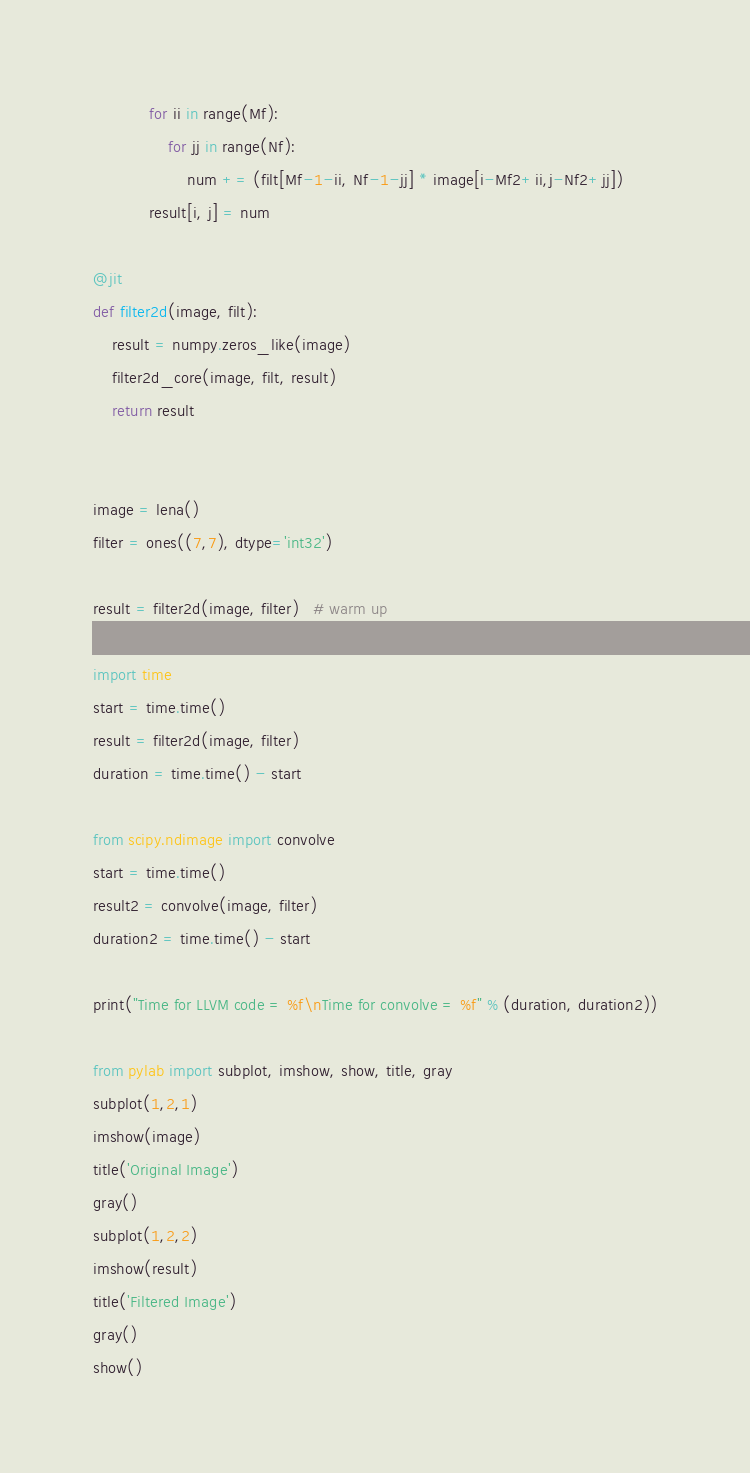Convert code to text. <code><loc_0><loc_0><loc_500><loc_500><_Python_>            for ii in range(Mf):
                for jj in range(Nf):
                    num += (filt[Mf-1-ii, Nf-1-jj] * image[i-Mf2+ii,j-Nf2+jj])
            result[i, j] = num

@jit
def filter2d(image, filt):
    result = numpy.zeros_like(image)
    filter2d_core(image, filt, result)
    return result


image = lena()
filter = ones((7,7), dtype='int32')

result = filter2d(image, filter)   # warm up

import time
start = time.time()
result = filter2d(image, filter)
duration = time.time() - start

from scipy.ndimage import convolve
start = time.time()
result2 = convolve(image, filter)
duration2 = time.time() - start

print("Time for LLVM code = %f\nTime for convolve = %f" % (duration, duration2))

from pylab import subplot, imshow, show, title, gray
subplot(1,2,1)
imshow(image)
title('Original Image')
gray()
subplot(1,2,2)
imshow(result)
title('Filtered Image')
gray()
show()
</code> 